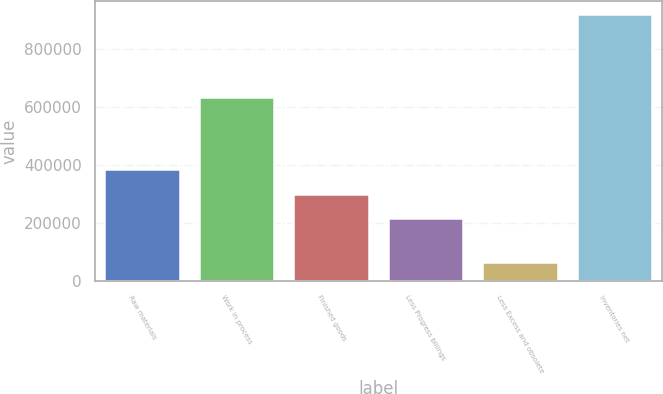<chart> <loc_0><loc_0><loc_500><loc_500><bar_chart><fcel>Raw materials<fcel>Work in process<fcel>Finished goods<fcel>Less Progress billings<fcel>Less Excess and obsolete<fcel>Inventories net<nl><fcel>386920<fcel>633352<fcel>301658<fcel>216396<fcel>66629<fcel>919251<nl></chart> 